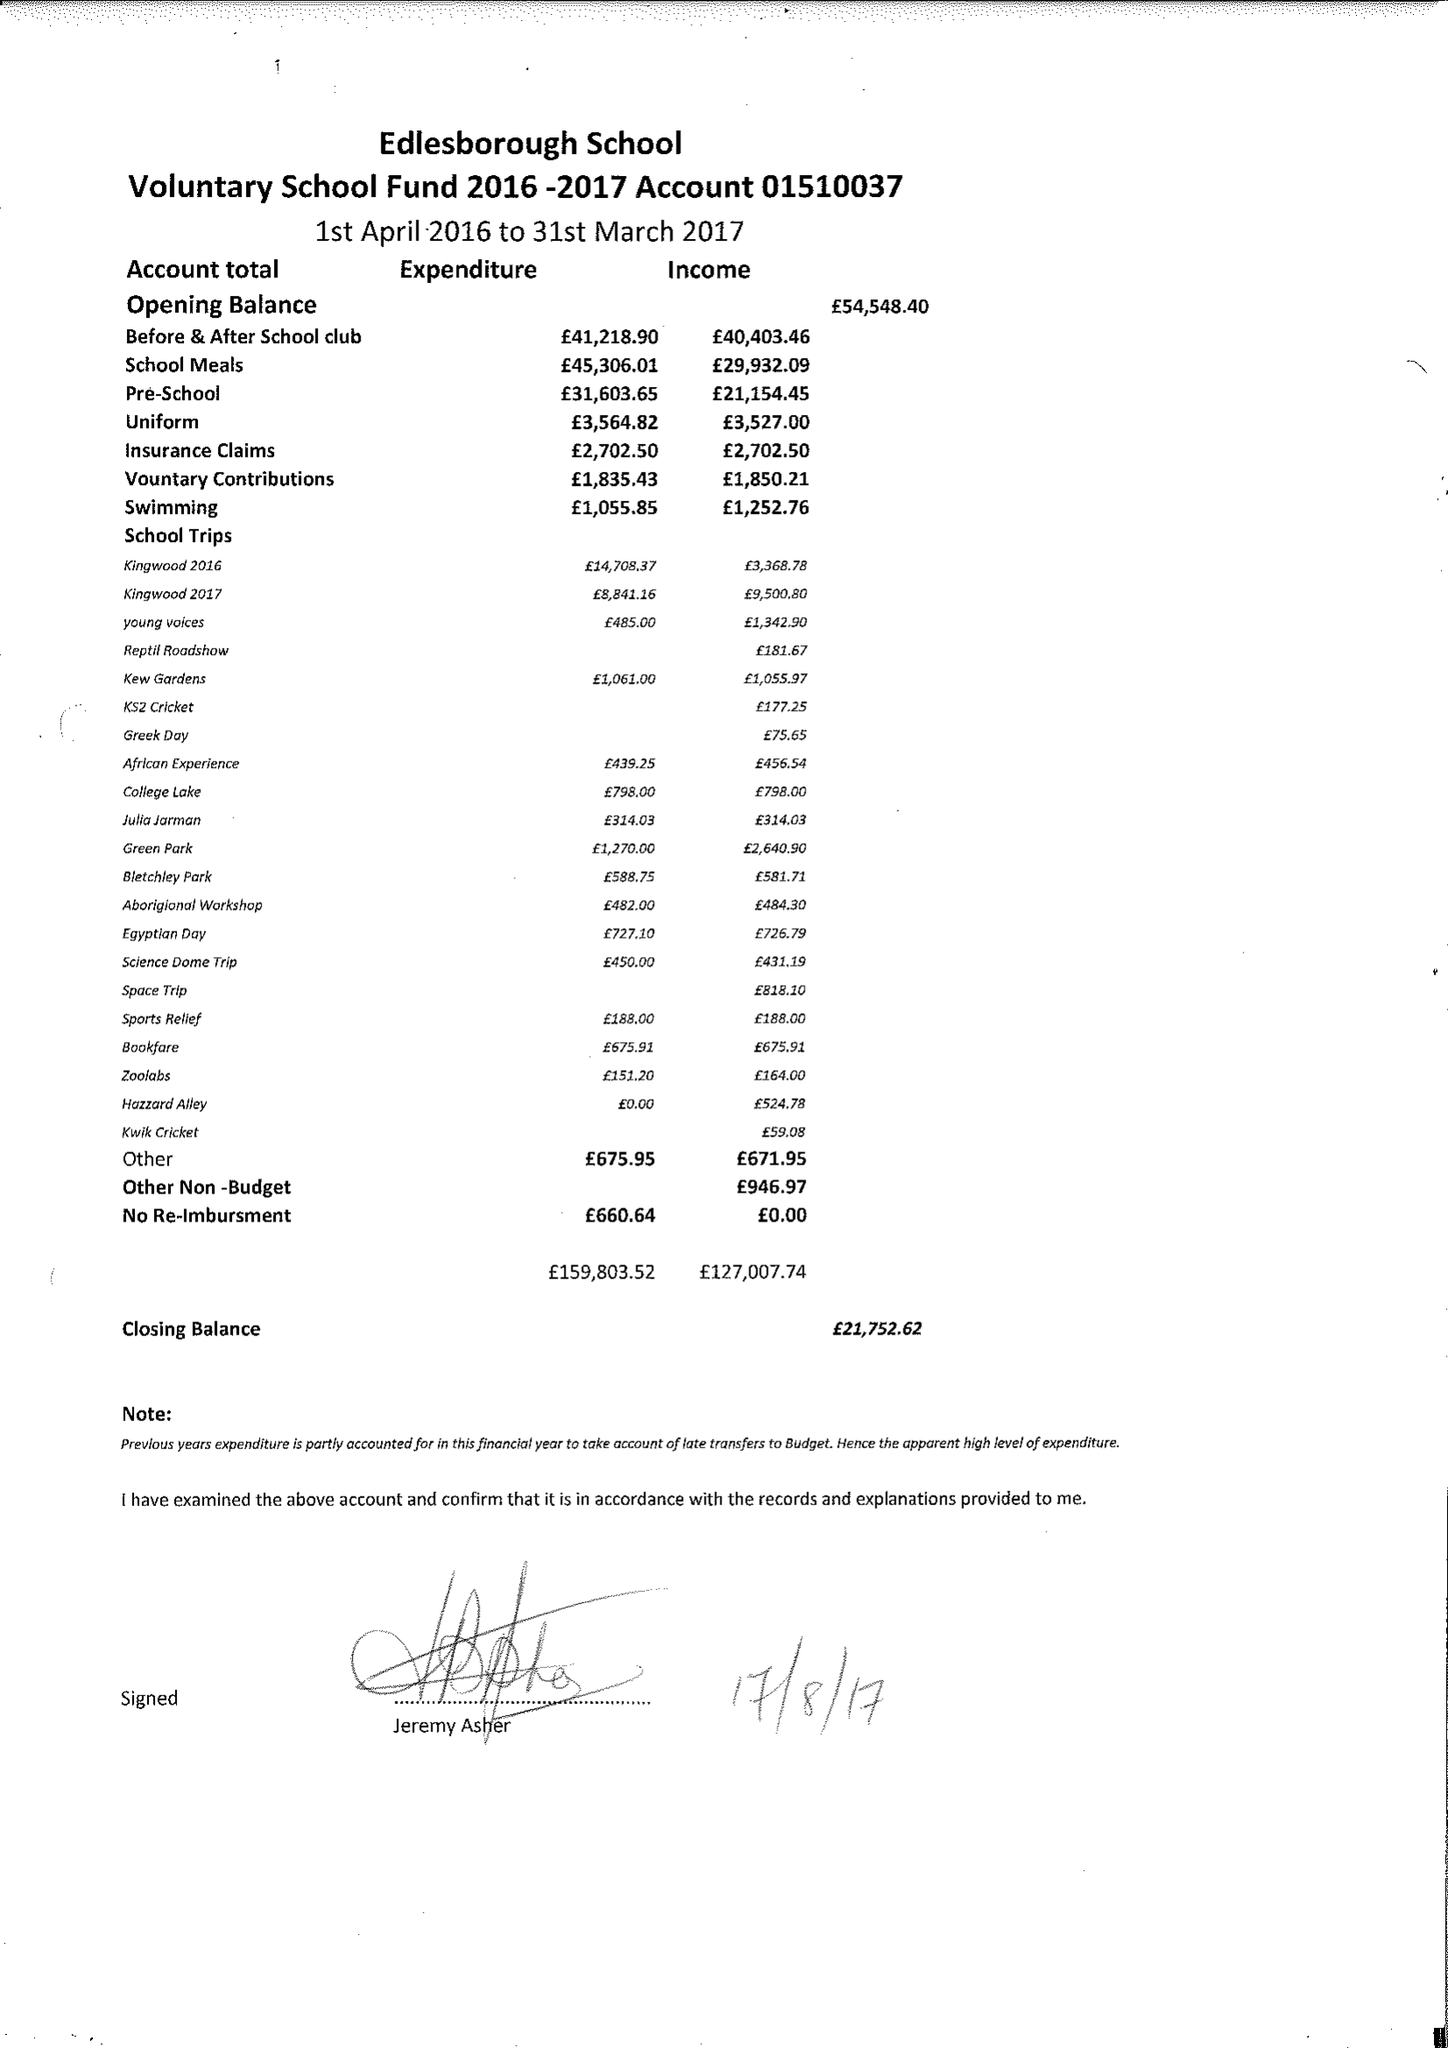What is the value for the spending_annually_in_british_pounds?
Answer the question using a single word or phrase. 159803.52 